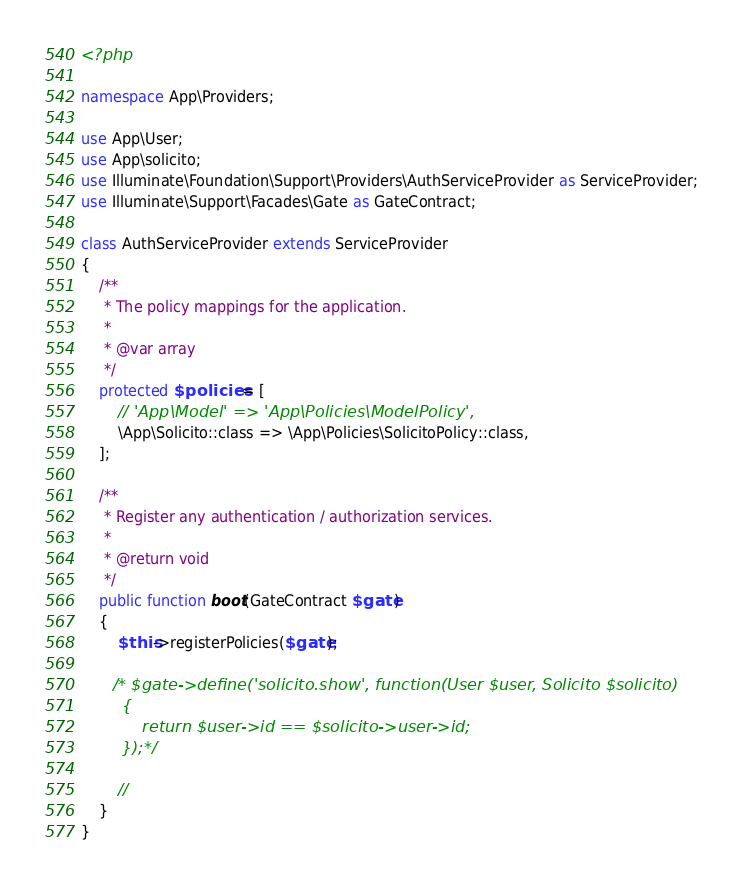<code> <loc_0><loc_0><loc_500><loc_500><_PHP_><?php

namespace App\Providers;

use App\User;
use App\solicito;
use Illuminate\Foundation\Support\Providers\AuthServiceProvider as ServiceProvider;
use Illuminate\Support\Facades\Gate as GateContract;

class AuthServiceProvider extends ServiceProvider
{
    /**
     * The policy mappings for the application.
     *
     * @var array
     */
    protected $policies = [
        // 'App\Model' => 'App\Policies\ModelPolicy',
        \App\Solicito::class => \App\Policies\SolicitoPolicy::class,
    ];

    /**
     * Register any authentication / authorization services.
     *
     * @return void
     */
    public function boot(GateContract $gate)
    {
        $this->registerPolicies($gate);

       /* $gate->define('solicito.show', function(User $user, Solicito $solicito)
        {
            return $user->id == $solicito->user->id;
        });*/

        //
    }
}
</code> 